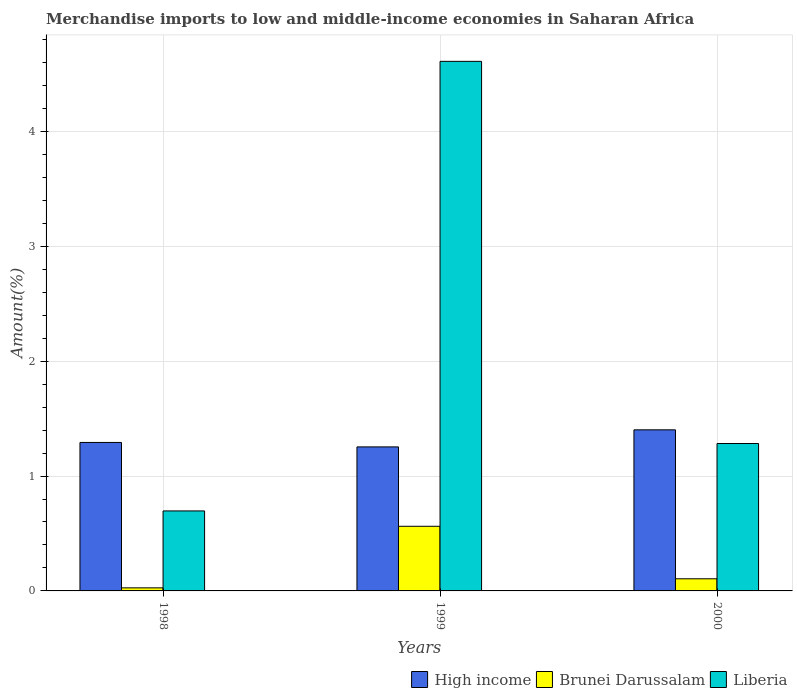How many different coloured bars are there?
Make the answer very short. 3. How many groups of bars are there?
Your response must be concise. 3. Are the number of bars per tick equal to the number of legend labels?
Your answer should be very brief. Yes. How many bars are there on the 1st tick from the left?
Give a very brief answer. 3. How many bars are there on the 1st tick from the right?
Make the answer very short. 3. What is the label of the 3rd group of bars from the left?
Give a very brief answer. 2000. In how many cases, is the number of bars for a given year not equal to the number of legend labels?
Your answer should be very brief. 0. What is the percentage of amount earned from merchandise imports in Brunei Darussalam in 1999?
Provide a short and direct response. 0.56. Across all years, what is the maximum percentage of amount earned from merchandise imports in Liberia?
Provide a short and direct response. 4.61. Across all years, what is the minimum percentage of amount earned from merchandise imports in Brunei Darussalam?
Make the answer very short. 0.03. In which year was the percentage of amount earned from merchandise imports in Liberia maximum?
Provide a succinct answer. 1999. In which year was the percentage of amount earned from merchandise imports in High income minimum?
Offer a terse response. 1999. What is the total percentage of amount earned from merchandise imports in High income in the graph?
Give a very brief answer. 3.95. What is the difference between the percentage of amount earned from merchandise imports in High income in 1998 and that in 1999?
Ensure brevity in your answer.  0.04. What is the difference between the percentage of amount earned from merchandise imports in Brunei Darussalam in 2000 and the percentage of amount earned from merchandise imports in High income in 1999?
Your response must be concise. -1.15. What is the average percentage of amount earned from merchandise imports in Brunei Darussalam per year?
Offer a very short reply. 0.23. In the year 2000, what is the difference between the percentage of amount earned from merchandise imports in Brunei Darussalam and percentage of amount earned from merchandise imports in High income?
Your response must be concise. -1.3. In how many years, is the percentage of amount earned from merchandise imports in Brunei Darussalam greater than 2.2 %?
Offer a very short reply. 0. What is the ratio of the percentage of amount earned from merchandise imports in High income in 1999 to that in 2000?
Give a very brief answer. 0.89. Is the difference between the percentage of amount earned from merchandise imports in Brunei Darussalam in 1998 and 1999 greater than the difference between the percentage of amount earned from merchandise imports in High income in 1998 and 1999?
Your answer should be very brief. No. What is the difference between the highest and the second highest percentage of amount earned from merchandise imports in Brunei Darussalam?
Your answer should be very brief. 0.46. What is the difference between the highest and the lowest percentage of amount earned from merchandise imports in Brunei Darussalam?
Give a very brief answer. 0.54. In how many years, is the percentage of amount earned from merchandise imports in Liberia greater than the average percentage of amount earned from merchandise imports in Liberia taken over all years?
Your answer should be compact. 1. What does the 3rd bar from the left in 1998 represents?
Make the answer very short. Liberia. How many bars are there?
Provide a short and direct response. 9. Are all the bars in the graph horizontal?
Provide a succinct answer. No. What is the difference between two consecutive major ticks on the Y-axis?
Your answer should be compact. 1. Where does the legend appear in the graph?
Ensure brevity in your answer.  Bottom right. What is the title of the graph?
Ensure brevity in your answer.  Merchandise imports to low and middle-income economies in Saharan Africa. What is the label or title of the X-axis?
Offer a very short reply. Years. What is the label or title of the Y-axis?
Provide a short and direct response. Amount(%). What is the Amount(%) of High income in 1998?
Your answer should be very brief. 1.29. What is the Amount(%) of Brunei Darussalam in 1998?
Your response must be concise. 0.03. What is the Amount(%) of Liberia in 1998?
Your answer should be compact. 0.7. What is the Amount(%) of High income in 1999?
Your answer should be compact. 1.25. What is the Amount(%) of Brunei Darussalam in 1999?
Offer a very short reply. 0.56. What is the Amount(%) of Liberia in 1999?
Your response must be concise. 4.61. What is the Amount(%) of High income in 2000?
Offer a very short reply. 1.4. What is the Amount(%) of Brunei Darussalam in 2000?
Provide a succinct answer. 0.11. What is the Amount(%) in Liberia in 2000?
Give a very brief answer. 1.28. Across all years, what is the maximum Amount(%) of High income?
Your answer should be very brief. 1.4. Across all years, what is the maximum Amount(%) of Brunei Darussalam?
Provide a succinct answer. 0.56. Across all years, what is the maximum Amount(%) in Liberia?
Offer a very short reply. 4.61. Across all years, what is the minimum Amount(%) of High income?
Keep it short and to the point. 1.25. Across all years, what is the minimum Amount(%) of Brunei Darussalam?
Keep it short and to the point. 0.03. Across all years, what is the minimum Amount(%) of Liberia?
Your response must be concise. 0.7. What is the total Amount(%) in High income in the graph?
Offer a very short reply. 3.95. What is the total Amount(%) of Brunei Darussalam in the graph?
Your answer should be compact. 0.69. What is the total Amount(%) of Liberia in the graph?
Offer a terse response. 6.59. What is the difference between the Amount(%) in High income in 1998 and that in 1999?
Keep it short and to the point. 0.04. What is the difference between the Amount(%) of Brunei Darussalam in 1998 and that in 1999?
Give a very brief answer. -0.54. What is the difference between the Amount(%) of Liberia in 1998 and that in 1999?
Your answer should be very brief. -3.91. What is the difference between the Amount(%) of High income in 1998 and that in 2000?
Your answer should be very brief. -0.11. What is the difference between the Amount(%) of Brunei Darussalam in 1998 and that in 2000?
Give a very brief answer. -0.08. What is the difference between the Amount(%) of Liberia in 1998 and that in 2000?
Keep it short and to the point. -0.59. What is the difference between the Amount(%) of High income in 1999 and that in 2000?
Make the answer very short. -0.15. What is the difference between the Amount(%) of Brunei Darussalam in 1999 and that in 2000?
Provide a short and direct response. 0.46. What is the difference between the Amount(%) in Liberia in 1999 and that in 2000?
Provide a succinct answer. 3.33. What is the difference between the Amount(%) of High income in 1998 and the Amount(%) of Brunei Darussalam in 1999?
Provide a succinct answer. 0.73. What is the difference between the Amount(%) in High income in 1998 and the Amount(%) in Liberia in 1999?
Your answer should be very brief. -3.32. What is the difference between the Amount(%) of Brunei Darussalam in 1998 and the Amount(%) of Liberia in 1999?
Give a very brief answer. -4.58. What is the difference between the Amount(%) in High income in 1998 and the Amount(%) in Brunei Darussalam in 2000?
Offer a very short reply. 1.19. What is the difference between the Amount(%) of High income in 1998 and the Amount(%) of Liberia in 2000?
Provide a succinct answer. 0.01. What is the difference between the Amount(%) in Brunei Darussalam in 1998 and the Amount(%) in Liberia in 2000?
Provide a succinct answer. -1.26. What is the difference between the Amount(%) of High income in 1999 and the Amount(%) of Brunei Darussalam in 2000?
Make the answer very short. 1.15. What is the difference between the Amount(%) of High income in 1999 and the Amount(%) of Liberia in 2000?
Provide a short and direct response. -0.03. What is the difference between the Amount(%) in Brunei Darussalam in 1999 and the Amount(%) in Liberia in 2000?
Your answer should be compact. -0.72. What is the average Amount(%) in High income per year?
Make the answer very short. 1.32. What is the average Amount(%) in Brunei Darussalam per year?
Provide a short and direct response. 0.23. What is the average Amount(%) in Liberia per year?
Make the answer very short. 2.2. In the year 1998, what is the difference between the Amount(%) in High income and Amount(%) in Brunei Darussalam?
Offer a very short reply. 1.27. In the year 1998, what is the difference between the Amount(%) of High income and Amount(%) of Liberia?
Keep it short and to the point. 0.6. In the year 1998, what is the difference between the Amount(%) in Brunei Darussalam and Amount(%) in Liberia?
Make the answer very short. -0.67. In the year 1999, what is the difference between the Amount(%) in High income and Amount(%) in Brunei Darussalam?
Provide a succinct answer. 0.69. In the year 1999, what is the difference between the Amount(%) in High income and Amount(%) in Liberia?
Make the answer very short. -3.36. In the year 1999, what is the difference between the Amount(%) of Brunei Darussalam and Amount(%) of Liberia?
Your response must be concise. -4.05. In the year 2000, what is the difference between the Amount(%) in High income and Amount(%) in Brunei Darussalam?
Your answer should be compact. 1.3. In the year 2000, what is the difference between the Amount(%) of High income and Amount(%) of Liberia?
Make the answer very short. 0.12. In the year 2000, what is the difference between the Amount(%) in Brunei Darussalam and Amount(%) in Liberia?
Keep it short and to the point. -1.18. What is the ratio of the Amount(%) of High income in 1998 to that in 1999?
Your response must be concise. 1.03. What is the ratio of the Amount(%) of Brunei Darussalam in 1998 to that in 1999?
Keep it short and to the point. 0.05. What is the ratio of the Amount(%) of Liberia in 1998 to that in 1999?
Provide a succinct answer. 0.15. What is the ratio of the Amount(%) of High income in 1998 to that in 2000?
Give a very brief answer. 0.92. What is the ratio of the Amount(%) in Brunei Darussalam in 1998 to that in 2000?
Make the answer very short. 0.25. What is the ratio of the Amount(%) of Liberia in 1998 to that in 2000?
Give a very brief answer. 0.54. What is the ratio of the Amount(%) of High income in 1999 to that in 2000?
Ensure brevity in your answer.  0.89. What is the ratio of the Amount(%) in Brunei Darussalam in 1999 to that in 2000?
Offer a terse response. 5.33. What is the ratio of the Amount(%) in Liberia in 1999 to that in 2000?
Keep it short and to the point. 3.59. What is the difference between the highest and the second highest Amount(%) of High income?
Ensure brevity in your answer.  0.11. What is the difference between the highest and the second highest Amount(%) of Brunei Darussalam?
Offer a very short reply. 0.46. What is the difference between the highest and the second highest Amount(%) in Liberia?
Offer a very short reply. 3.33. What is the difference between the highest and the lowest Amount(%) of High income?
Provide a short and direct response. 0.15. What is the difference between the highest and the lowest Amount(%) in Brunei Darussalam?
Your answer should be compact. 0.54. What is the difference between the highest and the lowest Amount(%) in Liberia?
Provide a succinct answer. 3.91. 